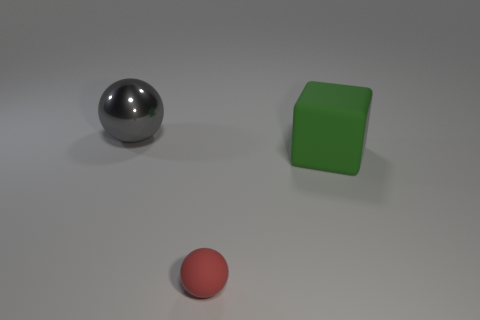Is there any other thing that is the same size as the red thing?
Provide a succinct answer. No. What number of objects are either spheres that are in front of the large metallic object or large blocks on the right side of the small red sphere?
Offer a terse response. 2. There is a tiny red thing that is the same shape as the big gray thing; what material is it?
Your answer should be compact. Rubber. What number of rubber objects are either cubes or large red cubes?
Give a very brief answer. 1. There is a thing that is the same material as the block; what shape is it?
Provide a short and direct response. Sphere. What number of large gray metal things have the same shape as the tiny red matte object?
Offer a terse response. 1. Does the big object that is to the left of the big rubber block have the same shape as the rubber object in front of the big green cube?
Make the answer very short. Yes. How many things are either tiny blue rubber cubes or big metallic spheres behind the tiny matte sphere?
Keep it short and to the point. 1. How many rubber cubes are the same size as the gray metallic ball?
Your response must be concise. 1. How many red objects are either tiny rubber things or spheres?
Give a very brief answer. 1. 